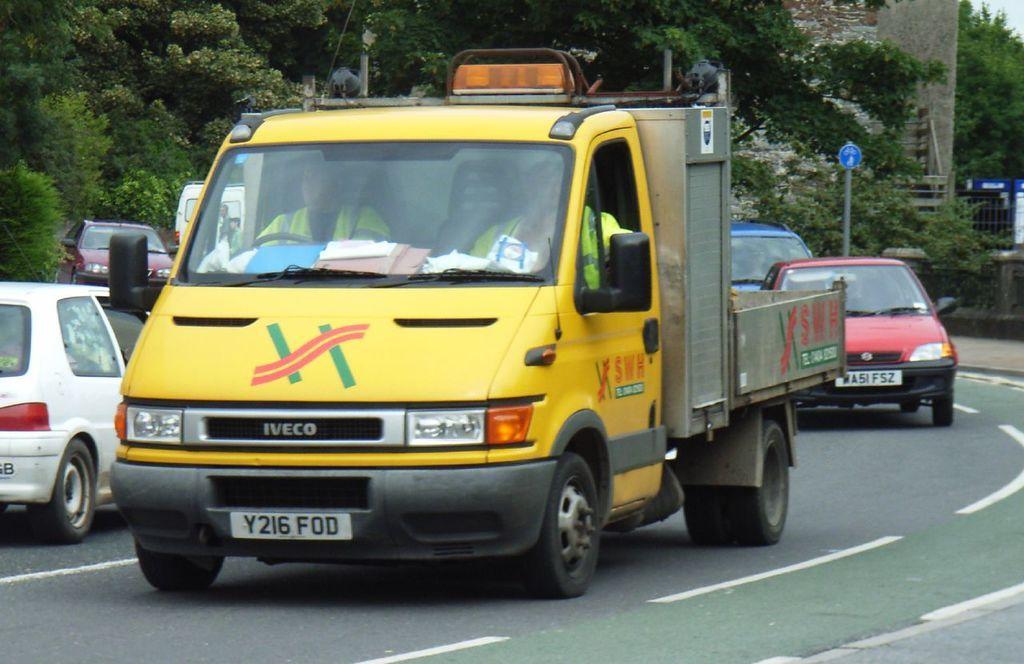Please provide a concise description of this image. In this image I can see few vehicles on road. Back I can see few trees,signboard,fencing,pole and the wall. 